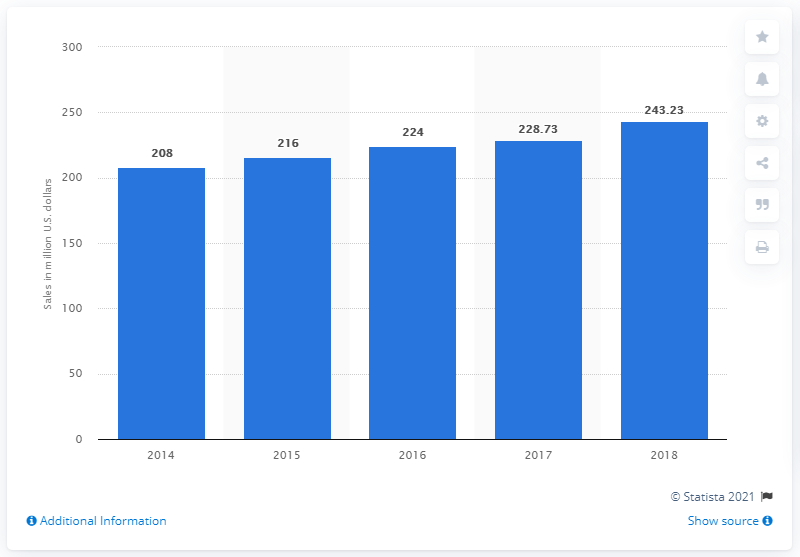Identify some key points in this picture. In 2018, the global sales of Molly Maid were valued at approximately 243.23 million dollars. 